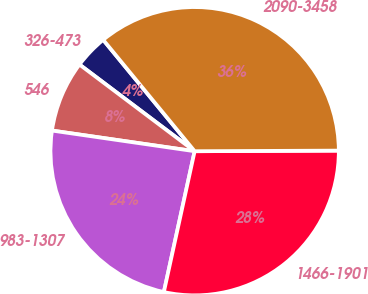<chart> <loc_0><loc_0><loc_500><loc_500><pie_chart><fcel>326-473<fcel>546<fcel>983-1307<fcel>1466-1901<fcel>2090-3458<nl><fcel>3.79%<fcel>7.98%<fcel>23.86%<fcel>28.49%<fcel>35.87%<nl></chart> 